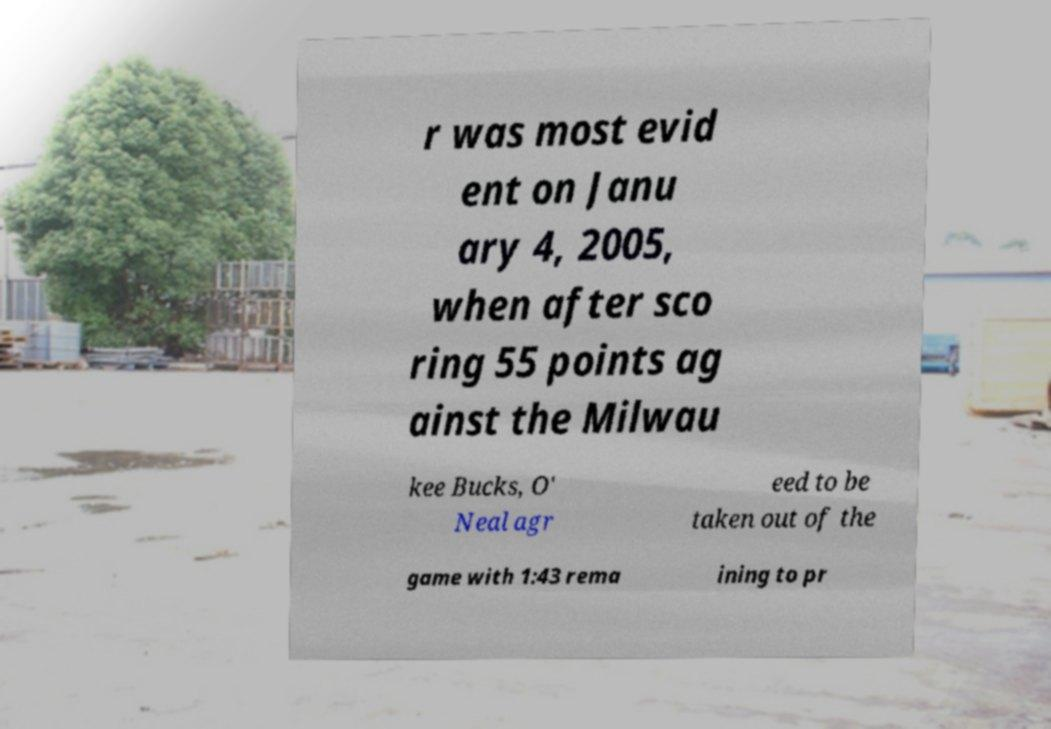Can you read and provide the text displayed in the image?This photo seems to have some interesting text. Can you extract and type it out for me? r was most evid ent on Janu ary 4, 2005, when after sco ring 55 points ag ainst the Milwau kee Bucks, O' Neal agr eed to be taken out of the game with 1:43 rema ining to pr 